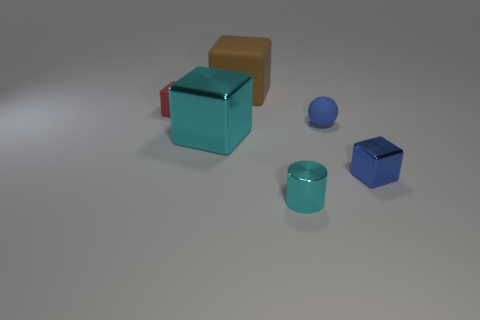Subtract 1 cubes. How many cubes are left? 3 Subtract all brown blocks. How many blocks are left? 3 Subtract all red cubes. How many cubes are left? 3 Add 2 large shiny cylinders. How many objects exist? 8 Subtract all yellow blocks. Subtract all gray balls. How many blocks are left? 4 Subtract all blocks. How many objects are left? 2 Add 5 tiny blue metallic blocks. How many tiny blue metallic blocks are left? 6 Add 6 tiny cyan shiny objects. How many tiny cyan shiny objects exist? 7 Subtract 0 purple cubes. How many objects are left? 6 Subtract all large blue objects. Subtract all tiny blue things. How many objects are left? 4 